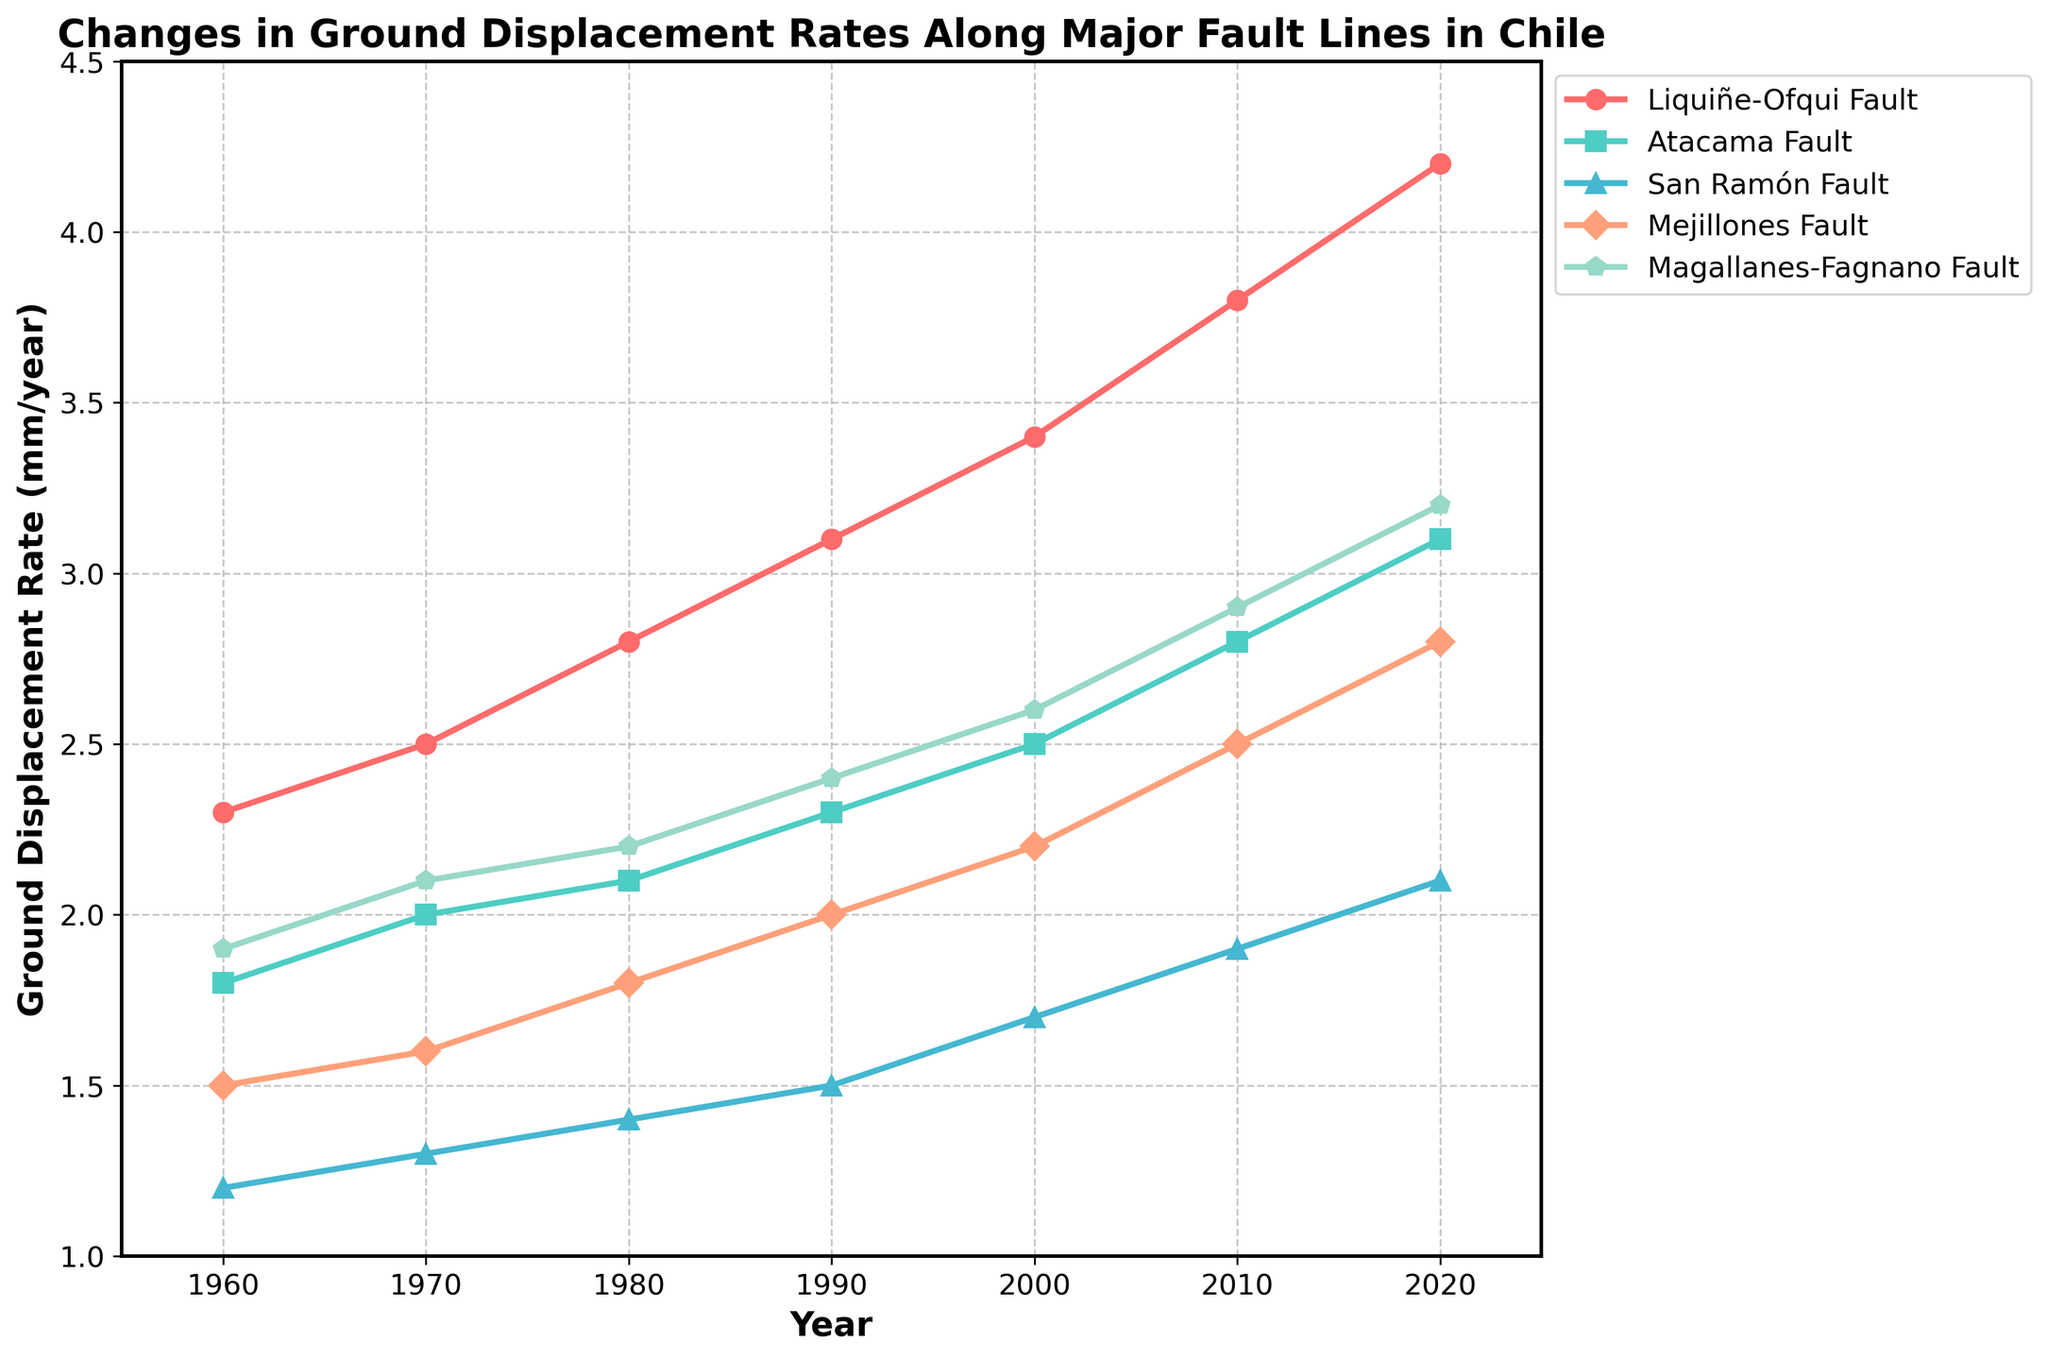What is the ground displacement rate for the Liquiñe-Ofqui Fault in the year 2000? Find the line representing the Liquiñe-Ofqui Fault and look at the value corresponding to the year 2000.
Answer: 3.4 mm/year Which fault shows the greatest overall increase in ground displacement rate from 1960 to 2020? Calculate the difference for each fault between the values in 2020 and 1960, and identify the fault with the largest increase: Liquiñe-Ofqui Fault (4.2 - 2.3 = 1.9), Atacama Fault (3.1 - 1.8 = 1.3), San Ramón Fault (2.1 - 1.2 = 0.9), Mejillones Fault (2.8 - 1.5 = 1.3), Magallanes-Fagnano Fault (3.2 - 1.9 = 1.3).
Answer: Liquiñe-Ofqui Fault Between which two consecutive decades did the Atacama Fault see the largest increase in its ground displacement rate? Calculate the difference in displacement rate for the Atacama Fault between all consecutive decades: (2.0 - 1.8 = 0.2), (2.1 - 2.0 = 0.1), (2.3 - 2.1 = 0.2), (2.5 - 2.3 = 0.2), (2.8 - 2.5 = 0.3), (3.1 - 2.8 = 0.3). The two largest increases are between 2000-2010 and 2010-2020, both showing an increase of 0.3.
Answer: 2000-2010 and 2010-2020 What is the average ground displacement rate for the San Ramón Fault from 1960 to 2020? Sum the displacement rates for San Ramón Fault for each decade and divide by the number of decades: (1.2 + 1.3 + 1.4 + 1.5 + 1.7 + 1.9 + 2.1) / 7 = 11.1 / 7
Answer: 1.59 mm/year In which year did the Liquiñe-Ofqui Fault's ground displacement rate surpass 3.0 mm/year? Locate the data points for Liquiñe-Ofqui Fault and find when the value surpasses 3.0 mm/year. This happened in 1990 when the rate was 3.1 mm/year.
Answer: 1990 How much did the ground displacement rate for the Mejillones Fault increase from 2010 to 2020? Subtract the displacement rate for the Mejillones Fault in 2010 from that in 2020: 2.8 - 2.5 = 0.3
Answer: 0.3 mm/year Which fault had the lowest displacement rate in the year 2010? Compare the displacement rates for all faults in 2010: Liquiñe-Ofqui Fault (3.8), Atacama Fault (2.8), San Ramón Fault (1.9), Mejillones Fault (2.5), Magallanes-Fagnano Fault (2.9). The San Ramón Fault had the lowest rate of 1.9 mm/year in 2010.
Answer: San Ramón Fault Is there any decade where all the faults showed an increase in displacement rate compared to the previous decade? Compare the displacement data of each fault for consecutive decades to see if there is any decade where all faults' displacement rates increased: every decade shows increases except between 1990 and 2000 for Mejillones Fault where the rate increased by 0.2 (from 2.0 to 2.2).
Answer: Yes, every decade shows an increase Which fault showed the most variability in its displacement rates from 1960 to 2020? Examine the range (difference between maximum and minimum values) for each fault: Liquiñe-Ofqui Fault (4.2 - 2.3 = 1.9), Atacama Fault (3.1 - 1.8 = 1.3), San Ramón Fault (2.1 - 1.2 = 0.9), Mejillones Fault (2.8 - 1.5 = 1.3), Magallanes-Fagnano Fault (3.2 - 1.9 = 1.3). The Liquiñe-Ofqui Fault shows the highest variability of 1.9 mm/year.
Answer: Liquiñe-Ofqui Fault 